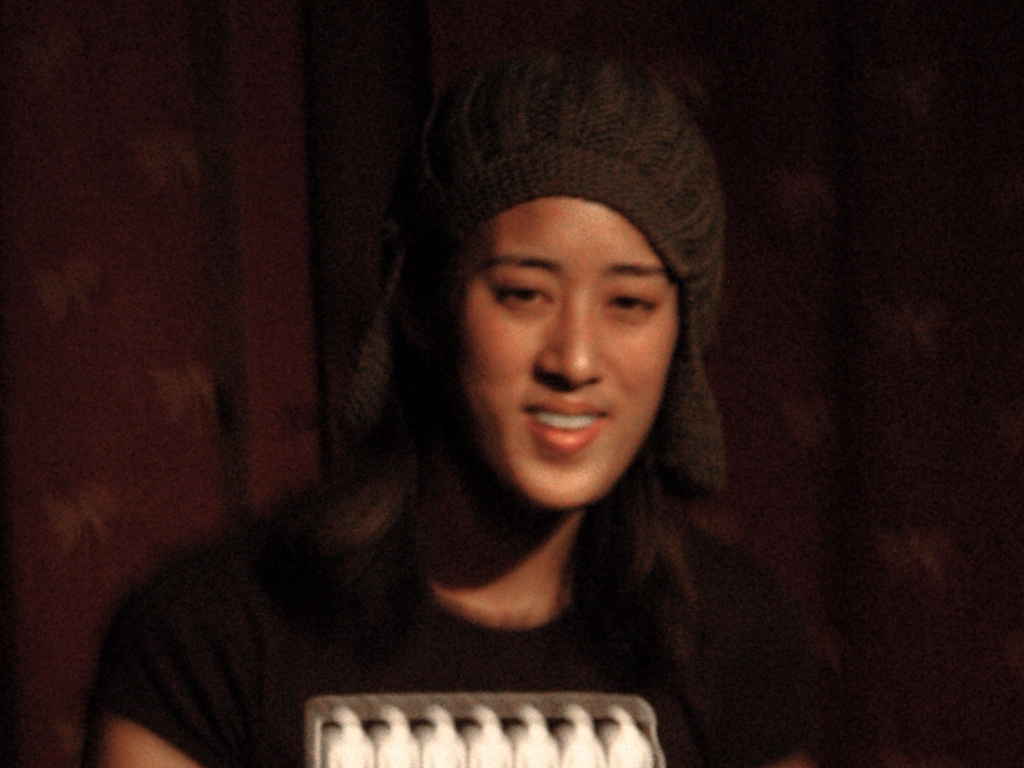What kind of improvements could be made to enhance the quality of this photo? To enhance this photo, one could start by adjusting the focus to make the image sharper and bring out details, especially around the subject's face. Reducing noise through post-processing software could also help, as well as correcting the lighting to evenly illuminate the subject's features. For future photos, using a tripod or stabilizing the camera could prevent blurriness, and better lighting equipment could improve clarity and detail. 